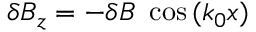Convert formula to latex. <formula><loc_0><loc_0><loc_500><loc_500>\delta B _ { z } = - \delta B \ \cos { ( k _ { 0 } x ) }</formula> 